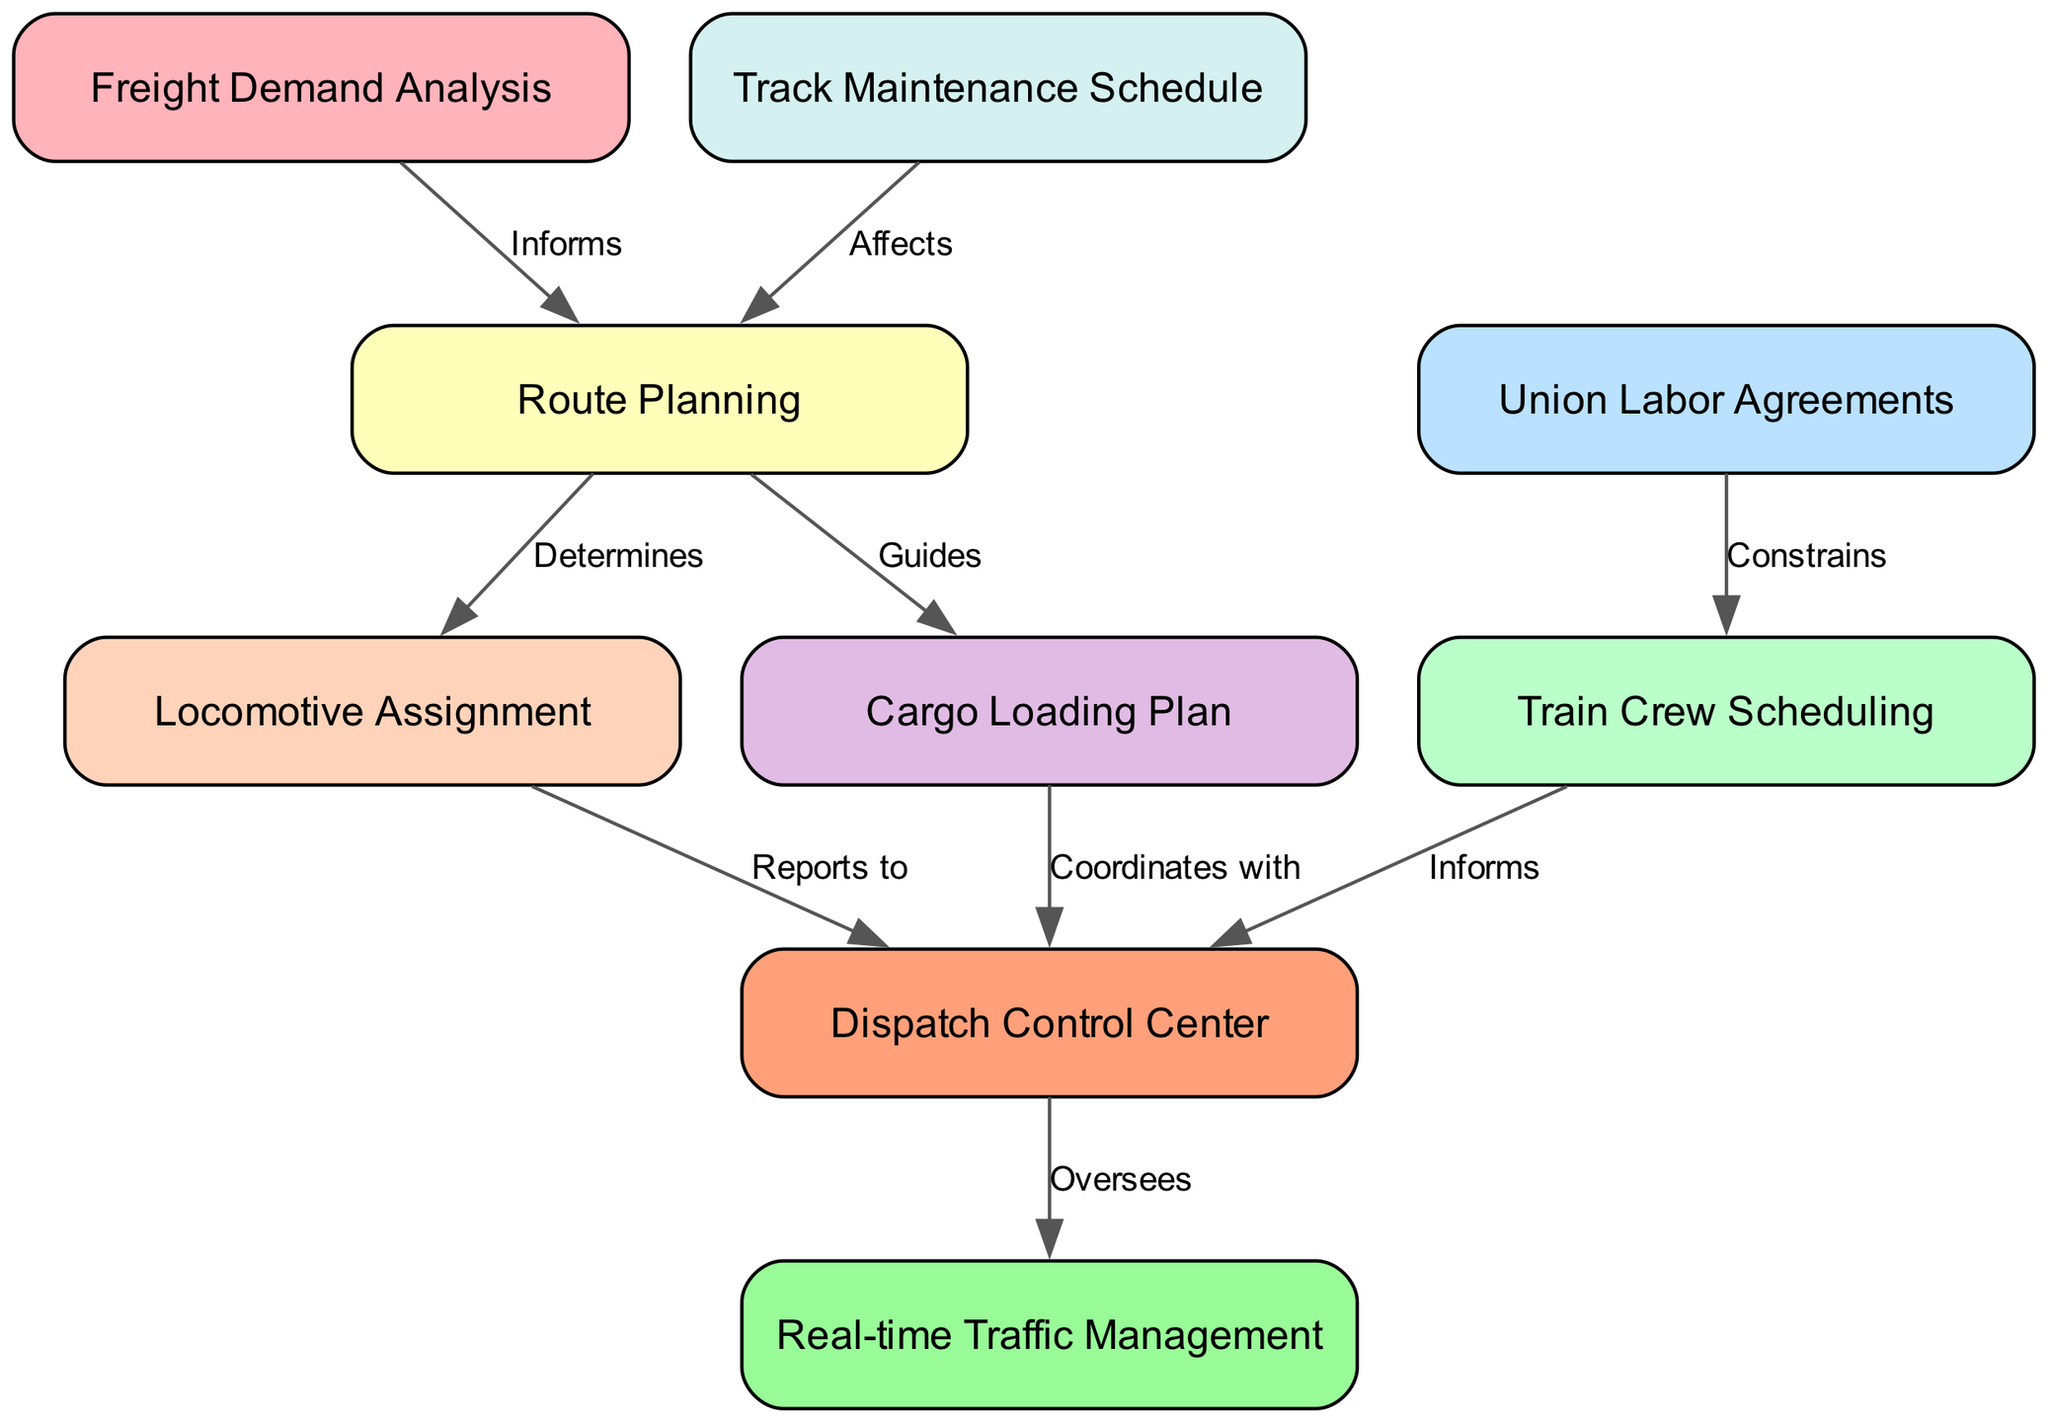How many nodes are in the diagram? The diagram lists a total of 9 different nodes that represent various stages of the freight train scheduling and dispatching process. This is obtained by simply counting each unique process represented in the nodes array.
Answer: 9 What is the relationship between "Freight Demand Analysis" and "Route Planning"? "Freight Demand Analysis" informs "Route Planning," establishing how demand influences the decisions made in route selection. This is determined by the directed edge showing the relationship and the label on the edge explaining the nature of the connection.
Answer: Informs Which process constrains the "Train Crew Scheduling"? The "Union Labor Agreements" constrain the "Train Crew Scheduling," indicating that labor agreements dictate or limit how crew scheduling can be managed. This is evident from the directed edge and its label.
Answer: Union Labor Agreements What does the "Route Planning" process determine? "Route Planning" determines both "Locomotive Assignment" and "Cargo Loading Plan." This is identified by observing the outgoing edges from the "Route Planning" node, each labeled with "Determines" and "Guides" respectively, indicating these processes are based on route planning decisions.
Answer: Locomotive Assignment, Cargo Loading Plan What does the "Dispatch Control Center" oversee? The "Dispatch Control Center" oversees "Real-time Traffic Management," indicating it has the responsibility to manage and monitor traffic flow in real-time based on earlier processes. The relationship is shown by a directed edge labeled "Oversees."
Answer: Real-time Traffic Management Which node affects "Route Planning"? The "Track Maintenance Schedule" affects "Route Planning," signifying that maintenance schedules for tracks impact the decisions made during route planning. This is confirmed from the directed edge and the relationship label "Affects."
Answer: Track Maintenance Schedule How many edges are in the diagram? The diagram consists of 8 edges, representing the various relationships between the nodes in the freight train scheduling and dispatching process. This number can be determined by counting each unique edge from the edges array.
Answer: 8 What is the role of "Train Crew Scheduling" in relation to "Dispatch Control Center"? "Train Crew Scheduling" informs the "Dispatch Control Center," meaning it provides necessary information regarding crew assignments for effective dispatching. The relationship is evident from the directed edge connecting the two nodes with the label "Informs."
Answer: Informs 